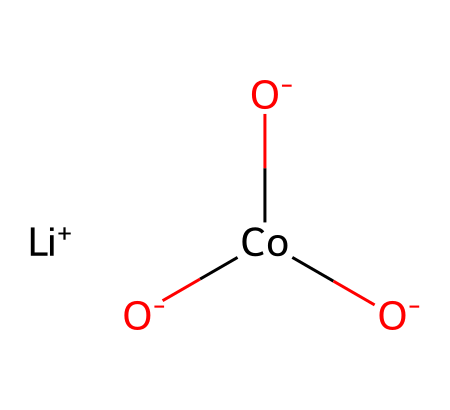What is the central metal ion in this compound? The chemical structure shows a cobalt atom (Co) as the central metal ion, which is connected to multiple oxygen atoms and interacts with the lithium ion.
Answer: cobalt How many oxygen atoms are present in the compound? By analyzing the structure, there are three oxygen atoms (O) indicated, each attached to the cobalt atom.
Answer: three Is the lithium in this compound a cation or an anion? The representation shows lithium as [Li+], indicating it carries a positive charge, classifying it as a cation.
Answer: cation What type of bonding is primarily present between lithium and oxygen? The interaction of lithium with oxygen is ionic, as lithium donates an electron to give it a positive charge, while oxygen carries a negative charge.
Answer: ionic What role does cobalt play in this battery technology compound? Cobalt functions as the central metal in lithium-cobalt oxide compounds, which are vital for improving energy density in lithium-ion batteries.
Answer: central metal Are there any functional groups clearly identifiable in this structure? The presence of the hydroxyl groups (due to the -O- connections) points to functional groups typically seen in metal oxides, essential for battery performance.
Answer: hydroxyl groups 